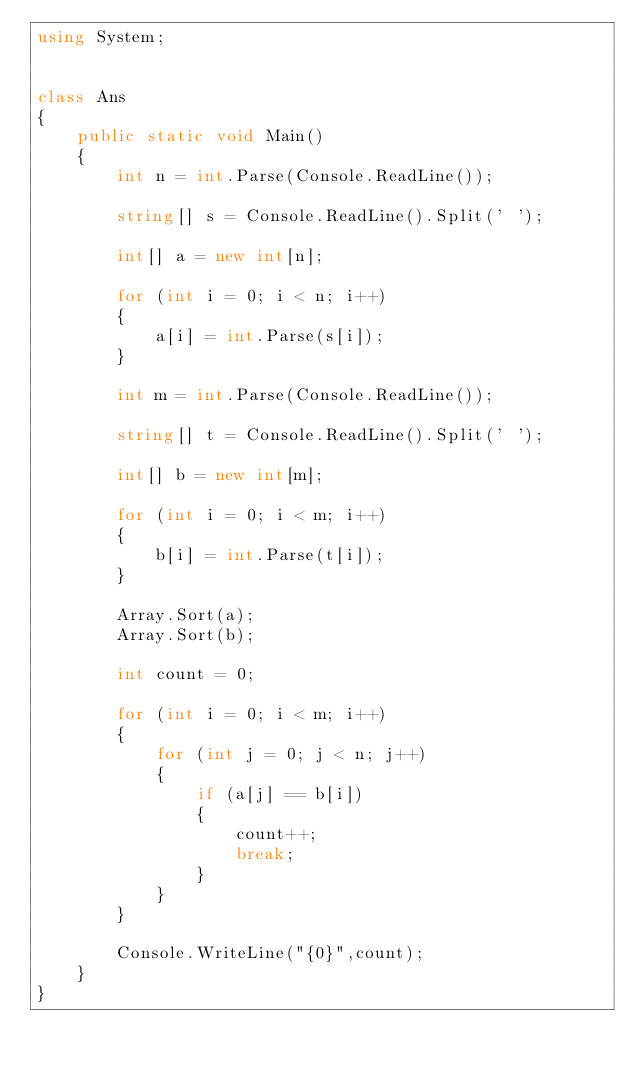<code> <loc_0><loc_0><loc_500><loc_500><_C#_>using System;


class Ans
{
    public static void Main()
    {
        int n = int.Parse(Console.ReadLine());

        string[] s = Console.ReadLine().Split(' ');

        int[] a = new int[n];

        for (int i = 0; i < n; i++)
        {
            a[i] = int.Parse(s[i]);
        }

        int m = int.Parse(Console.ReadLine());

        string[] t = Console.ReadLine().Split(' ');

        int[] b = new int[m];

        for (int i = 0; i < m; i++)
        {
            b[i] = int.Parse(t[i]);
        }

        Array.Sort(a);
        Array.Sort(b);

        int count = 0;

        for (int i = 0; i < m; i++)
        {
            for (int j = 0; j < n; j++)
            {
                if (a[j] == b[i])
                {
                    count++;
                    break;
                }
            }
        }

        Console.WriteLine("{0}",count);
    }
}</code> 